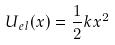<formula> <loc_0><loc_0><loc_500><loc_500>U _ { e l } ( x ) = \frac { 1 } { 2 } k x ^ { 2 }</formula> 